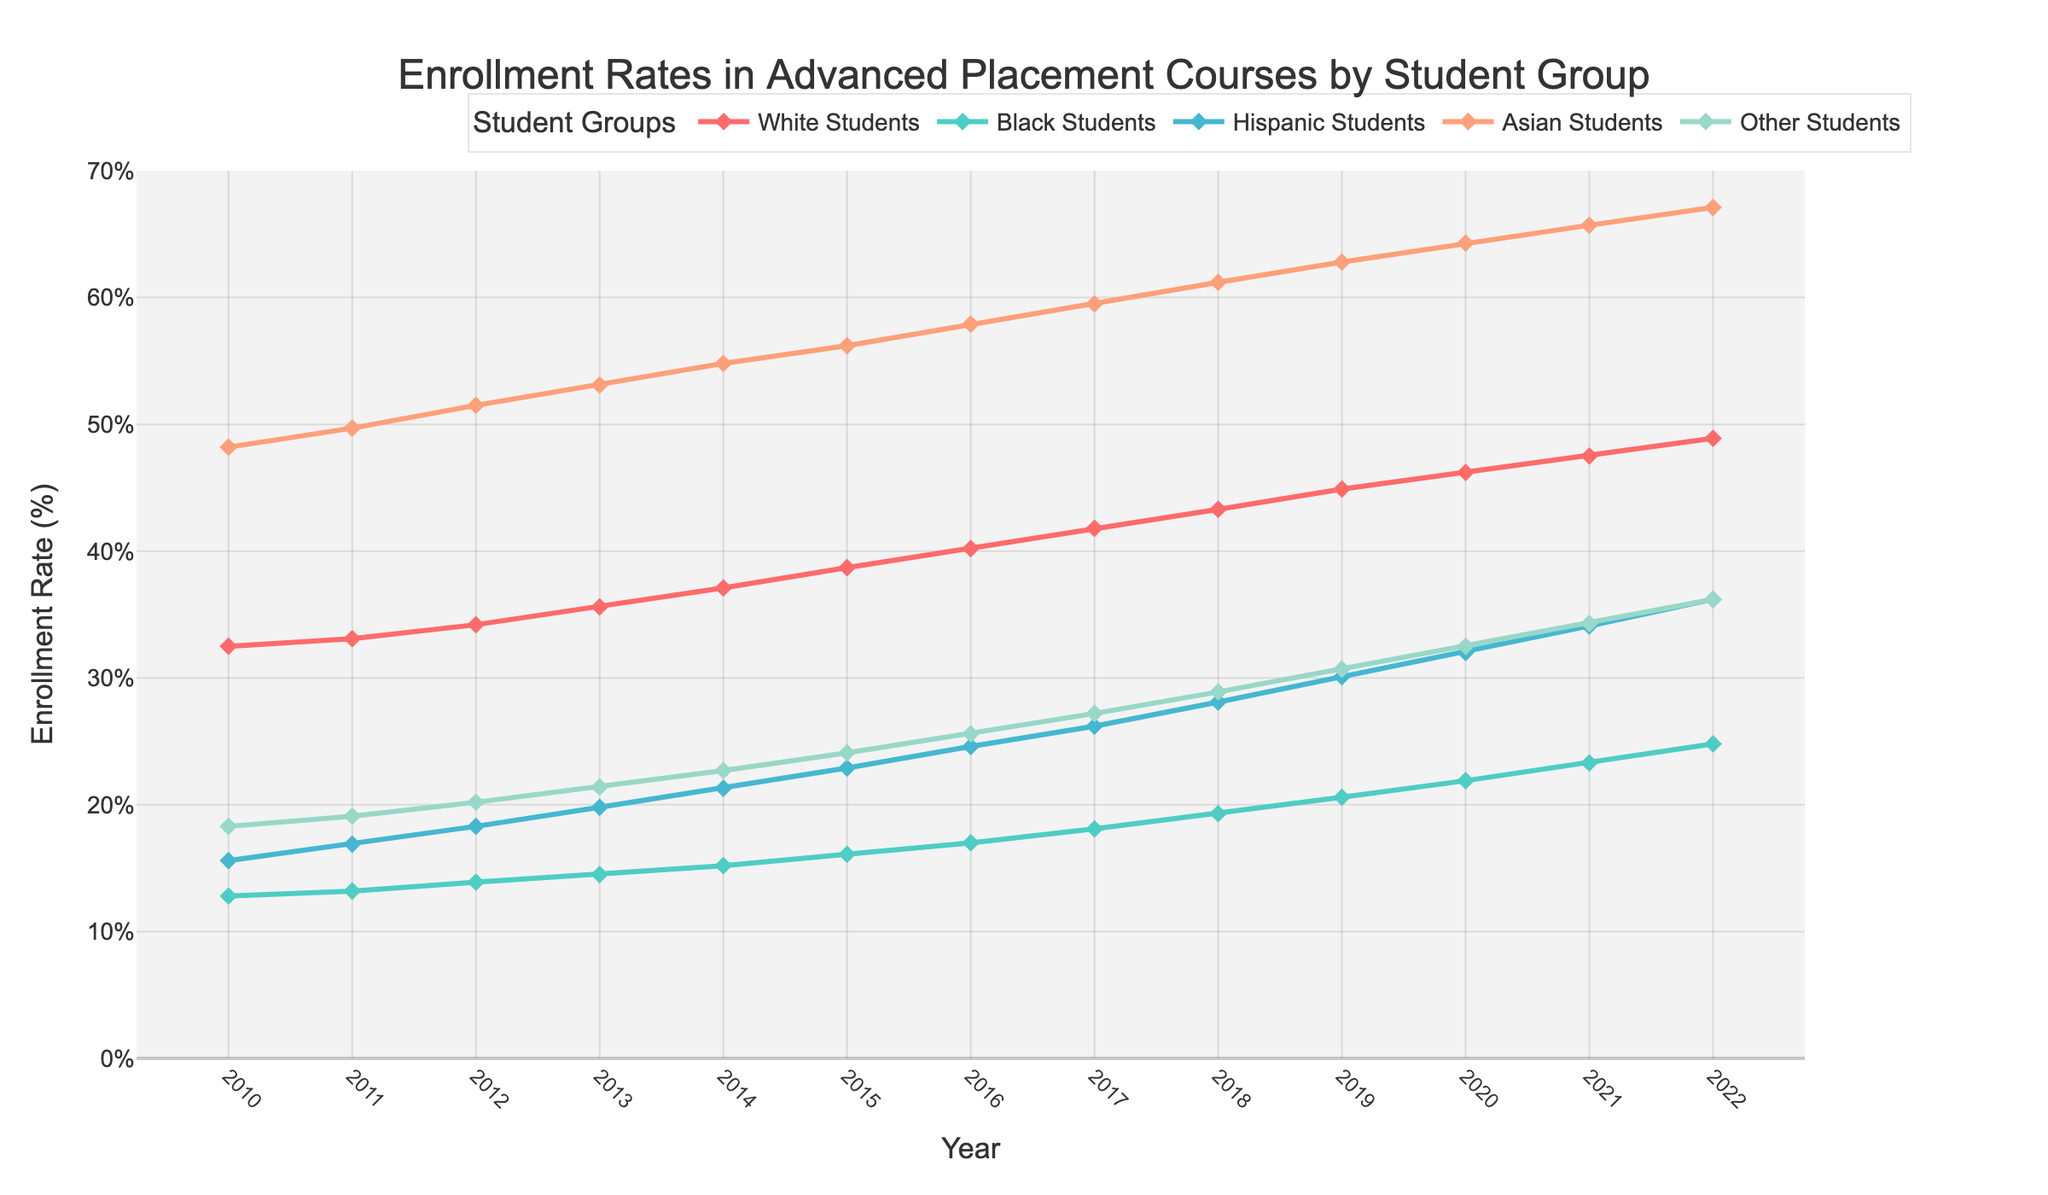Which student group had the highest enrollment rate in 2022? To find the group with the highest enrollment rate in 2022, look at the data points for each group in that year and identify the highest value. The data shows that Asian Students have the highest rate at 67.1%.
Answer: Asian Students How did the enrollment rate of Hispanic Students change from 2010 to 2015? Compare the enrollment rates of Hispanic students in 2010 and 2015. In 2010, the rate was 15.6%, and in 2015, it was 22.9%. So, the rate increased by 7.3 percentage points.
Answer: Increased by 7.3% Which student group had the smallest increase in enrollment rate from 2010 to 2022? Calculate the increase for each group over the period. The increases were: White Students (16.4%), Black Students (12%), Hispanic Students (20.6%), Asian Students (18.9%), Other Students (17.9%). The smallest increase was for Black Students (12%).
Answer: Black Students By how many percentage points did the enrollment rate of Black Students increase between 2013 and 2016? Subtract the 2013 rate from the 2016 rate. In 2013, it was 14.5%, and in 2016, it was 17.0%. The increase is 17.0% - 14.5% = 2.5%.
Answer: 2.5% Which two student groups had the closest enrollment rates in 2020? Compare the rates of all groups in 2020 and identify the pair with the smallest difference. White Students (46.2%), Black Students (21.9%), Hispanic Students (32.0%), Asian Students (64.3%), Other Students (32.5%). The closest rates are Hispanic Students and Other Students at 32.0% and 32.5%, respectively, with a difference of 0.5%.
Answer: Hispanic Students and Other Students What is the average enrollment rate of Asian Students across all years? Sum the enrollment rates of Asian Students for all years and divide by the number of years (13). The sum is 733.90%, so the average is 733.90% / 13 ≈ 56.45%.
Answer: 56.45% Which student group showed a steady increase in enrollment rates every year? Check the data for each group year by year to see which one consistently increases. All groups show steady increases, but the focus is on properly verifying each year that no year had a decrease.
Answer: All groups How much greater was the enrollment rate for Asian Students than Black Students in 2022? Subtract the 2022 rate for Black Students from the rate for Asian Students. For Black Students, it’s 24.8%, and for Asian Students, it’s 67.1%. So, the difference is 67.1% - 24.8% = 42.3%.
Answer: 42.3% What was the enrollment rate trend for Hispanic Students from 2015 to 2019? Check the yearly data for Hispanic Students from 2015 to 2019. The rates are 22.9%, 24.6%, 26.2%, 28.1%, and 30.1%, showing a consistent yearly increase.
Answer: Consistent increase In which year did White Students surpass a 40% enrollment rate? Identify the first year where White Students' rate exceeded 40%. In 2016, the rate was 40.2%, so White Students surpassed 40% that year.
Answer: 2016 